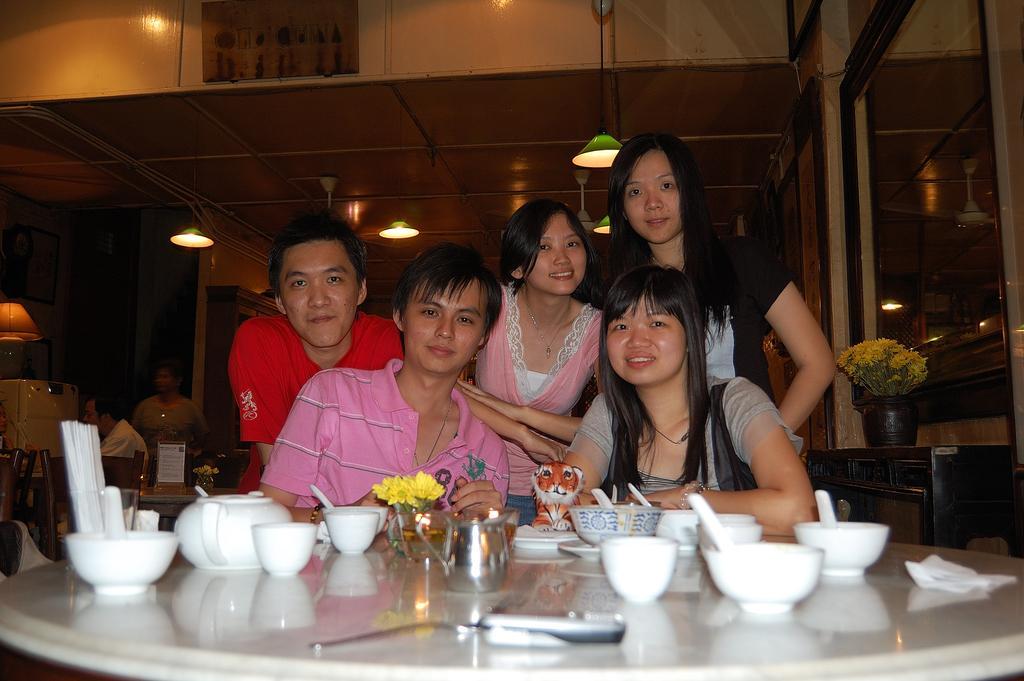How would you summarize this image in a sentence or two? In this image in the center there are a group of people, and there is a table. On the table there are some bowls, spoons, jar, flowers and a phone. In the background there is a flower pot, plants and some people, lamp, chairs, boxes, wall and some lights. At the top there is ceiling. 